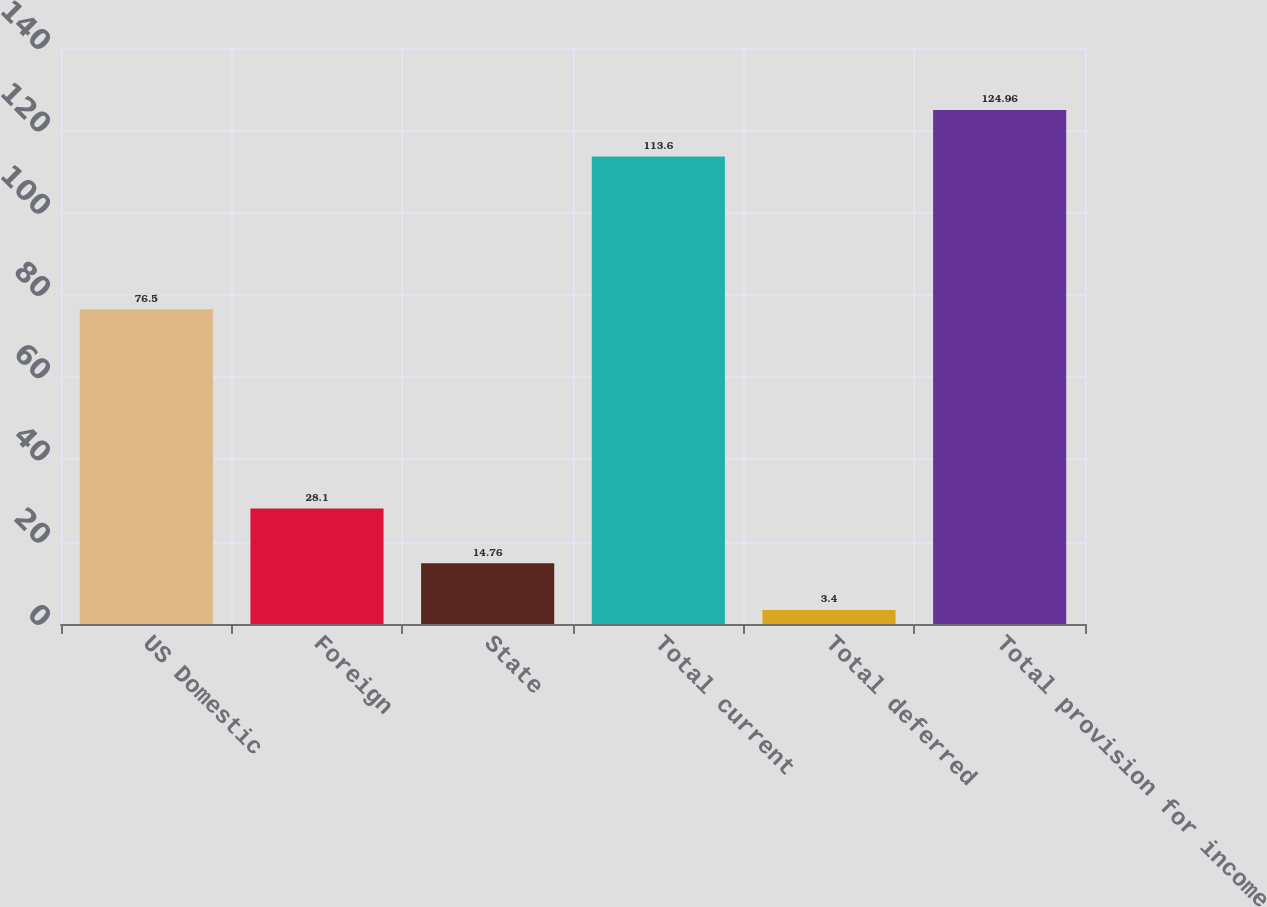<chart> <loc_0><loc_0><loc_500><loc_500><bar_chart><fcel>US Domestic<fcel>Foreign<fcel>State<fcel>Total current<fcel>Total deferred<fcel>Total provision for income<nl><fcel>76.5<fcel>28.1<fcel>14.76<fcel>113.6<fcel>3.4<fcel>124.96<nl></chart> 